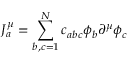Convert formula to latex. <formula><loc_0><loc_0><loc_500><loc_500>J _ { a } ^ { \mu } = \sum _ { b , c = 1 } ^ { N } c _ { a b c } \phi _ { b } \partial ^ { \mu } \phi _ { c }</formula> 